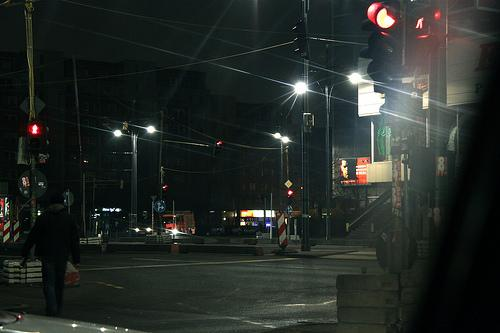For a product advertisement, describe the scene as an ideal setting for a night-time outdoor clothing campaign. Under the mesmerizing glow of streetlights, a young man confidently conquers the concrete jungle, casting a confident stride in his stylish jacket, proving that our clothing line is the perfect companion for the adventurous urban explorer. Using creative language, describe the scene involving the man and the street environment. Beneath the moonlit sky, a solitary figure wearing a jacket strides across the urban jungle's street, dwarfed by the towering buildings with dark windows and lit by the crimson glow of a traffic light perched upon a metal pole. For a multi-choice VQA task, what are the colors mixed in one of the street signs? Please provide two choices. B. Red and White In a casual style, describe what the person is doing, and how the street looks. Hey, there's this guy just walking across the street in his snazzy jacket, and the street has these cool white lines, buildings with dark windows, and traffic lights doing their thing. 